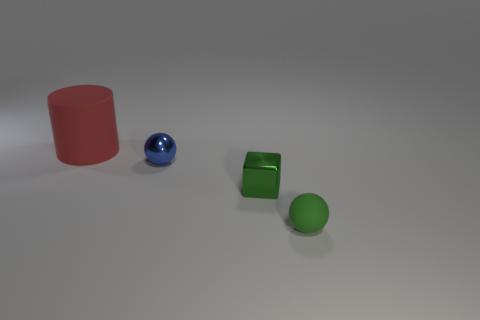There is a rubber object on the left side of the matte object that is to the right of the thing behind the blue metallic ball; what size is it?
Your response must be concise. Large. How many other objects are the same color as the large object?
Provide a short and direct response. 0. There is a green metallic object that is the same size as the blue metallic thing; what is its shape?
Give a very brief answer. Cube. How big is the sphere on the left side of the small green block?
Your answer should be compact. Small. There is a sphere on the right side of the green block; is its color the same as the small metallic thing that is in front of the tiny metallic ball?
Offer a terse response. Yes. The big cylinder that is on the left side of the tiny green thing that is on the left side of the matte object that is in front of the cylinder is made of what material?
Offer a terse response. Rubber. Is there a red object of the same size as the green rubber object?
Your answer should be compact. No. There is a blue sphere that is the same size as the metallic cube; what is its material?
Provide a short and direct response. Metal. What is the shape of the rubber object in front of the large red thing?
Give a very brief answer. Sphere. Do the thing left of the small blue metal thing and the small thing that is on the left side of the green cube have the same material?
Provide a short and direct response. No. 